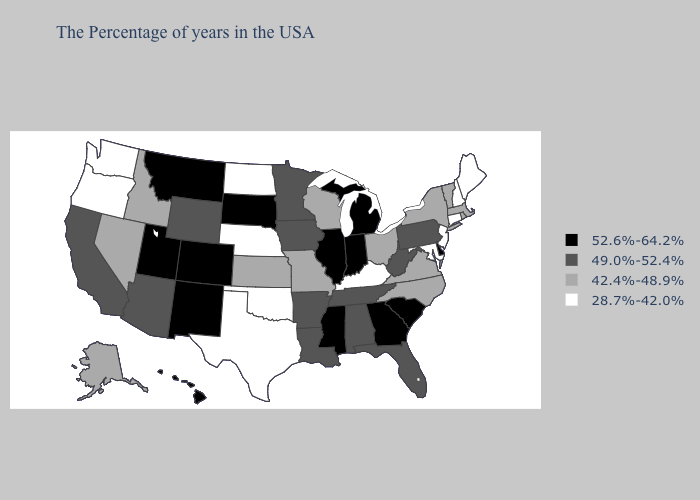How many symbols are there in the legend?
Answer briefly. 4. Does Maine have the highest value in the USA?
Answer briefly. No. Among the states that border Oklahoma , which have the highest value?
Write a very short answer. Colorado, New Mexico. Does Virginia have the lowest value in the South?
Answer briefly. No. What is the lowest value in the USA?
Keep it brief. 28.7%-42.0%. Name the states that have a value in the range 28.7%-42.0%?
Write a very short answer. Maine, New Hampshire, Connecticut, New Jersey, Maryland, Kentucky, Nebraska, Oklahoma, Texas, North Dakota, Washington, Oregon. What is the highest value in the West ?
Write a very short answer. 52.6%-64.2%. What is the value of Michigan?
Short answer required. 52.6%-64.2%. What is the lowest value in the South?
Concise answer only. 28.7%-42.0%. What is the value of Oklahoma?
Be succinct. 28.7%-42.0%. Does Oklahoma have the lowest value in the South?
Write a very short answer. Yes. Name the states that have a value in the range 42.4%-48.9%?
Keep it brief. Massachusetts, Rhode Island, Vermont, New York, Virginia, North Carolina, Ohio, Wisconsin, Missouri, Kansas, Idaho, Nevada, Alaska. Does the first symbol in the legend represent the smallest category?
Be succinct. No. Is the legend a continuous bar?
Give a very brief answer. No. Does Connecticut have the highest value in the USA?
Short answer required. No. 